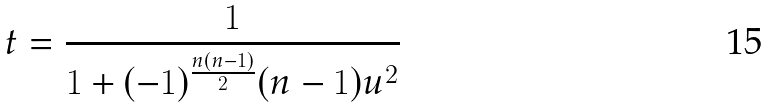<formula> <loc_0><loc_0><loc_500><loc_500>t = { \frac { 1 } { 1 + ( - 1 ) ^ { \frac { n ( n - 1 ) } { 2 } } ( n - 1 ) u ^ { 2 } } }</formula> 